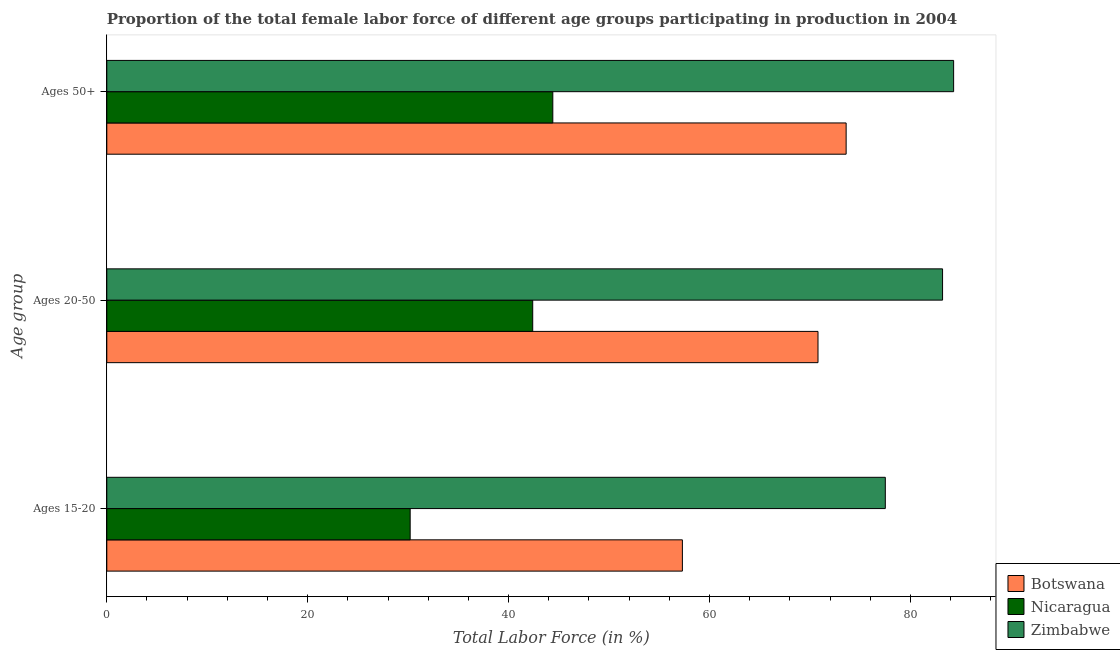How many bars are there on the 3rd tick from the bottom?
Give a very brief answer. 3. What is the label of the 3rd group of bars from the top?
Your answer should be very brief. Ages 15-20. What is the percentage of female labor force above age 50 in Nicaragua?
Give a very brief answer. 44.4. Across all countries, what is the maximum percentage of female labor force within the age group 15-20?
Offer a very short reply. 77.5. Across all countries, what is the minimum percentage of female labor force within the age group 15-20?
Ensure brevity in your answer.  30.2. In which country was the percentage of female labor force within the age group 20-50 maximum?
Make the answer very short. Zimbabwe. In which country was the percentage of female labor force above age 50 minimum?
Your response must be concise. Nicaragua. What is the total percentage of female labor force within the age group 20-50 in the graph?
Make the answer very short. 196.4. What is the difference between the percentage of female labor force within the age group 15-20 in Zimbabwe and that in Botswana?
Ensure brevity in your answer.  20.2. What is the difference between the percentage of female labor force within the age group 20-50 in Botswana and the percentage of female labor force above age 50 in Nicaragua?
Provide a succinct answer. 26.4. What is the average percentage of female labor force within the age group 20-50 per country?
Provide a short and direct response. 65.47. What is the difference between the percentage of female labor force above age 50 and percentage of female labor force within the age group 15-20 in Botswana?
Provide a succinct answer. 16.3. What is the ratio of the percentage of female labor force above age 50 in Botswana to that in Zimbabwe?
Your response must be concise. 0.87. What is the difference between the highest and the second highest percentage of female labor force above age 50?
Make the answer very short. 10.7. What is the difference between the highest and the lowest percentage of female labor force above age 50?
Your answer should be very brief. 39.9. In how many countries, is the percentage of female labor force within the age group 20-50 greater than the average percentage of female labor force within the age group 20-50 taken over all countries?
Your answer should be very brief. 2. What does the 1st bar from the top in Ages 20-50 represents?
Provide a succinct answer. Zimbabwe. What does the 1st bar from the bottom in Ages 20-50 represents?
Provide a short and direct response. Botswana. Is it the case that in every country, the sum of the percentage of female labor force within the age group 15-20 and percentage of female labor force within the age group 20-50 is greater than the percentage of female labor force above age 50?
Keep it short and to the point. Yes. How many bars are there?
Provide a short and direct response. 9. Does the graph contain any zero values?
Provide a succinct answer. No. Does the graph contain grids?
Offer a terse response. No. Where does the legend appear in the graph?
Offer a terse response. Bottom right. How many legend labels are there?
Make the answer very short. 3. How are the legend labels stacked?
Your answer should be very brief. Vertical. What is the title of the graph?
Your answer should be very brief. Proportion of the total female labor force of different age groups participating in production in 2004. Does "United Arab Emirates" appear as one of the legend labels in the graph?
Provide a short and direct response. No. What is the label or title of the Y-axis?
Provide a short and direct response. Age group. What is the Total Labor Force (in %) in Botswana in Ages 15-20?
Offer a terse response. 57.3. What is the Total Labor Force (in %) in Nicaragua in Ages 15-20?
Provide a succinct answer. 30.2. What is the Total Labor Force (in %) in Zimbabwe in Ages 15-20?
Ensure brevity in your answer.  77.5. What is the Total Labor Force (in %) in Botswana in Ages 20-50?
Make the answer very short. 70.8. What is the Total Labor Force (in %) in Nicaragua in Ages 20-50?
Offer a very short reply. 42.4. What is the Total Labor Force (in %) of Zimbabwe in Ages 20-50?
Your answer should be very brief. 83.2. What is the Total Labor Force (in %) of Botswana in Ages 50+?
Keep it short and to the point. 73.6. What is the Total Labor Force (in %) in Nicaragua in Ages 50+?
Your answer should be compact. 44.4. What is the Total Labor Force (in %) in Zimbabwe in Ages 50+?
Provide a succinct answer. 84.3. Across all Age group, what is the maximum Total Labor Force (in %) of Botswana?
Provide a succinct answer. 73.6. Across all Age group, what is the maximum Total Labor Force (in %) of Nicaragua?
Make the answer very short. 44.4. Across all Age group, what is the maximum Total Labor Force (in %) in Zimbabwe?
Provide a short and direct response. 84.3. Across all Age group, what is the minimum Total Labor Force (in %) in Botswana?
Provide a succinct answer. 57.3. Across all Age group, what is the minimum Total Labor Force (in %) of Nicaragua?
Make the answer very short. 30.2. Across all Age group, what is the minimum Total Labor Force (in %) in Zimbabwe?
Offer a terse response. 77.5. What is the total Total Labor Force (in %) in Botswana in the graph?
Offer a very short reply. 201.7. What is the total Total Labor Force (in %) in Nicaragua in the graph?
Your answer should be very brief. 117. What is the total Total Labor Force (in %) of Zimbabwe in the graph?
Make the answer very short. 245. What is the difference between the Total Labor Force (in %) of Botswana in Ages 15-20 and that in Ages 20-50?
Give a very brief answer. -13.5. What is the difference between the Total Labor Force (in %) in Botswana in Ages 15-20 and that in Ages 50+?
Provide a short and direct response. -16.3. What is the difference between the Total Labor Force (in %) in Zimbabwe in Ages 15-20 and that in Ages 50+?
Provide a succinct answer. -6.8. What is the difference between the Total Labor Force (in %) in Nicaragua in Ages 20-50 and that in Ages 50+?
Give a very brief answer. -2. What is the difference between the Total Labor Force (in %) of Botswana in Ages 15-20 and the Total Labor Force (in %) of Zimbabwe in Ages 20-50?
Your answer should be compact. -25.9. What is the difference between the Total Labor Force (in %) in Nicaragua in Ages 15-20 and the Total Labor Force (in %) in Zimbabwe in Ages 20-50?
Offer a very short reply. -53. What is the difference between the Total Labor Force (in %) in Nicaragua in Ages 15-20 and the Total Labor Force (in %) in Zimbabwe in Ages 50+?
Give a very brief answer. -54.1. What is the difference between the Total Labor Force (in %) in Botswana in Ages 20-50 and the Total Labor Force (in %) in Nicaragua in Ages 50+?
Provide a succinct answer. 26.4. What is the difference between the Total Labor Force (in %) in Nicaragua in Ages 20-50 and the Total Labor Force (in %) in Zimbabwe in Ages 50+?
Your response must be concise. -41.9. What is the average Total Labor Force (in %) in Botswana per Age group?
Make the answer very short. 67.23. What is the average Total Labor Force (in %) in Nicaragua per Age group?
Your response must be concise. 39. What is the average Total Labor Force (in %) in Zimbabwe per Age group?
Your answer should be very brief. 81.67. What is the difference between the Total Labor Force (in %) in Botswana and Total Labor Force (in %) in Nicaragua in Ages 15-20?
Give a very brief answer. 27.1. What is the difference between the Total Labor Force (in %) in Botswana and Total Labor Force (in %) in Zimbabwe in Ages 15-20?
Ensure brevity in your answer.  -20.2. What is the difference between the Total Labor Force (in %) of Nicaragua and Total Labor Force (in %) of Zimbabwe in Ages 15-20?
Your answer should be compact. -47.3. What is the difference between the Total Labor Force (in %) of Botswana and Total Labor Force (in %) of Nicaragua in Ages 20-50?
Offer a very short reply. 28.4. What is the difference between the Total Labor Force (in %) of Botswana and Total Labor Force (in %) of Zimbabwe in Ages 20-50?
Your answer should be compact. -12.4. What is the difference between the Total Labor Force (in %) of Nicaragua and Total Labor Force (in %) of Zimbabwe in Ages 20-50?
Ensure brevity in your answer.  -40.8. What is the difference between the Total Labor Force (in %) of Botswana and Total Labor Force (in %) of Nicaragua in Ages 50+?
Your answer should be compact. 29.2. What is the difference between the Total Labor Force (in %) of Botswana and Total Labor Force (in %) of Zimbabwe in Ages 50+?
Give a very brief answer. -10.7. What is the difference between the Total Labor Force (in %) in Nicaragua and Total Labor Force (in %) in Zimbabwe in Ages 50+?
Ensure brevity in your answer.  -39.9. What is the ratio of the Total Labor Force (in %) of Botswana in Ages 15-20 to that in Ages 20-50?
Your answer should be compact. 0.81. What is the ratio of the Total Labor Force (in %) of Nicaragua in Ages 15-20 to that in Ages 20-50?
Provide a short and direct response. 0.71. What is the ratio of the Total Labor Force (in %) of Zimbabwe in Ages 15-20 to that in Ages 20-50?
Keep it short and to the point. 0.93. What is the ratio of the Total Labor Force (in %) of Botswana in Ages 15-20 to that in Ages 50+?
Offer a very short reply. 0.78. What is the ratio of the Total Labor Force (in %) of Nicaragua in Ages 15-20 to that in Ages 50+?
Offer a very short reply. 0.68. What is the ratio of the Total Labor Force (in %) in Zimbabwe in Ages 15-20 to that in Ages 50+?
Your response must be concise. 0.92. What is the ratio of the Total Labor Force (in %) of Botswana in Ages 20-50 to that in Ages 50+?
Offer a very short reply. 0.96. What is the ratio of the Total Labor Force (in %) of Nicaragua in Ages 20-50 to that in Ages 50+?
Give a very brief answer. 0.95. What is the difference between the highest and the second highest Total Labor Force (in %) in Nicaragua?
Provide a short and direct response. 2. What is the difference between the highest and the lowest Total Labor Force (in %) in Botswana?
Keep it short and to the point. 16.3. What is the difference between the highest and the lowest Total Labor Force (in %) in Zimbabwe?
Your response must be concise. 6.8. 